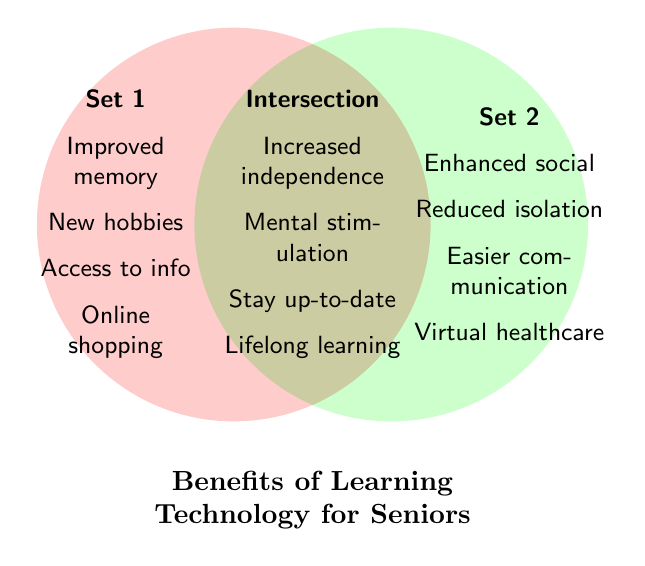What is the title of the Venn Diagram? The title is the large text that explains the overall topic of the Venn Diagram. It is located at the bottom-center of the figure and reads "Benefits of Learning Technology for Seniors".
Answer: Benefits of Learning Technology for Seniors What color is used for Set 1? The color for Set 1 can be determined from its distinct appearance in the Venn Diagram. Set 1 is represented with a pinkish-red color.
Answer: Pinkish-red What benefits are only in Set 1? To find the benefits unique to Set 1, look at the text placed on the left side of the Venn Diagram under "Set 1". These include "Improved memory", "New hobbies", "Access to info", and "Online shopping".
Answer: Improved memory, New hobbies, Access to info, Online shopping Name one benefit that intersects both sets. The intersection section, which is the overlapping area of the circles in the Venn Diagram, contains shared benefits. One of these benefits is "Increased independence".
Answer: Increased independence Compare the number of benefits in Set 1 and the Intersection. Which has more? To answer this, count the items listed in Set 1 and the Intersection areas. Set 1 has four benefits, and the Intersection also has four benefits. Both have the same number of benefits.
Answer: Both have the same Name all the benefits in Set 2. To find all the benefits specific to Set 2, refer to the right side of the Venn Diagram under "Set 2". The listed benefits are "Enhanced social", "Reduced isolation", "Easier communication", and "Virtual healthcare".
Answer: Enhanced social, Reduced isolation, Easier communication, Virtual healthcare Which benefits help to reduce isolation? According to the Venn Diagram, the benefit "Reduced isolation" is specifically listed under Set 2, which means it helps to reduce isolation.
Answer: Reduced isolation How many total benefits are mentioned in both sets including the intersection? Count the benefits listed under Set 1, Set 2, and the Intersection. There are 4 benefits in Set 1, 4 in Set 2, and 4 in the Intersection, making a total of 12 benefits.
Answer: 12 benefits What benefits contribute to mental health in the Venn Diagram? Benefits contributing to mental health are those like "Mental stimulation", which is listed in the Intersection area. This benefit supports cognitive health.
Answer: Mental stimulation 